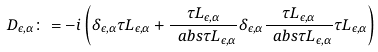<formula> <loc_0><loc_0><loc_500><loc_500>\ D _ { \epsilon , \alpha } \colon = - i \left ( \delta _ { \epsilon , \alpha } \tau L _ { \epsilon , \alpha } + \frac { \tau L _ { \epsilon , \alpha } } { \ a b s { \tau L _ { \epsilon , \alpha } } } \delta _ { \epsilon , \alpha } \frac { \tau L _ { \epsilon , \alpha } } { \ a b s { \tau L _ { \epsilon , \alpha } } } \tau L _ { \epsilon , \alpha } \right )</formula> 